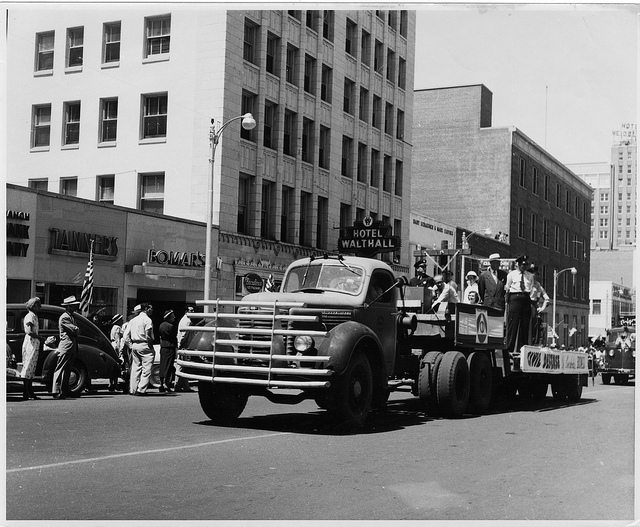Please transcribe the text in this image. HOTEL WALTHALL ANOH TANNHRS ROMAR'S 